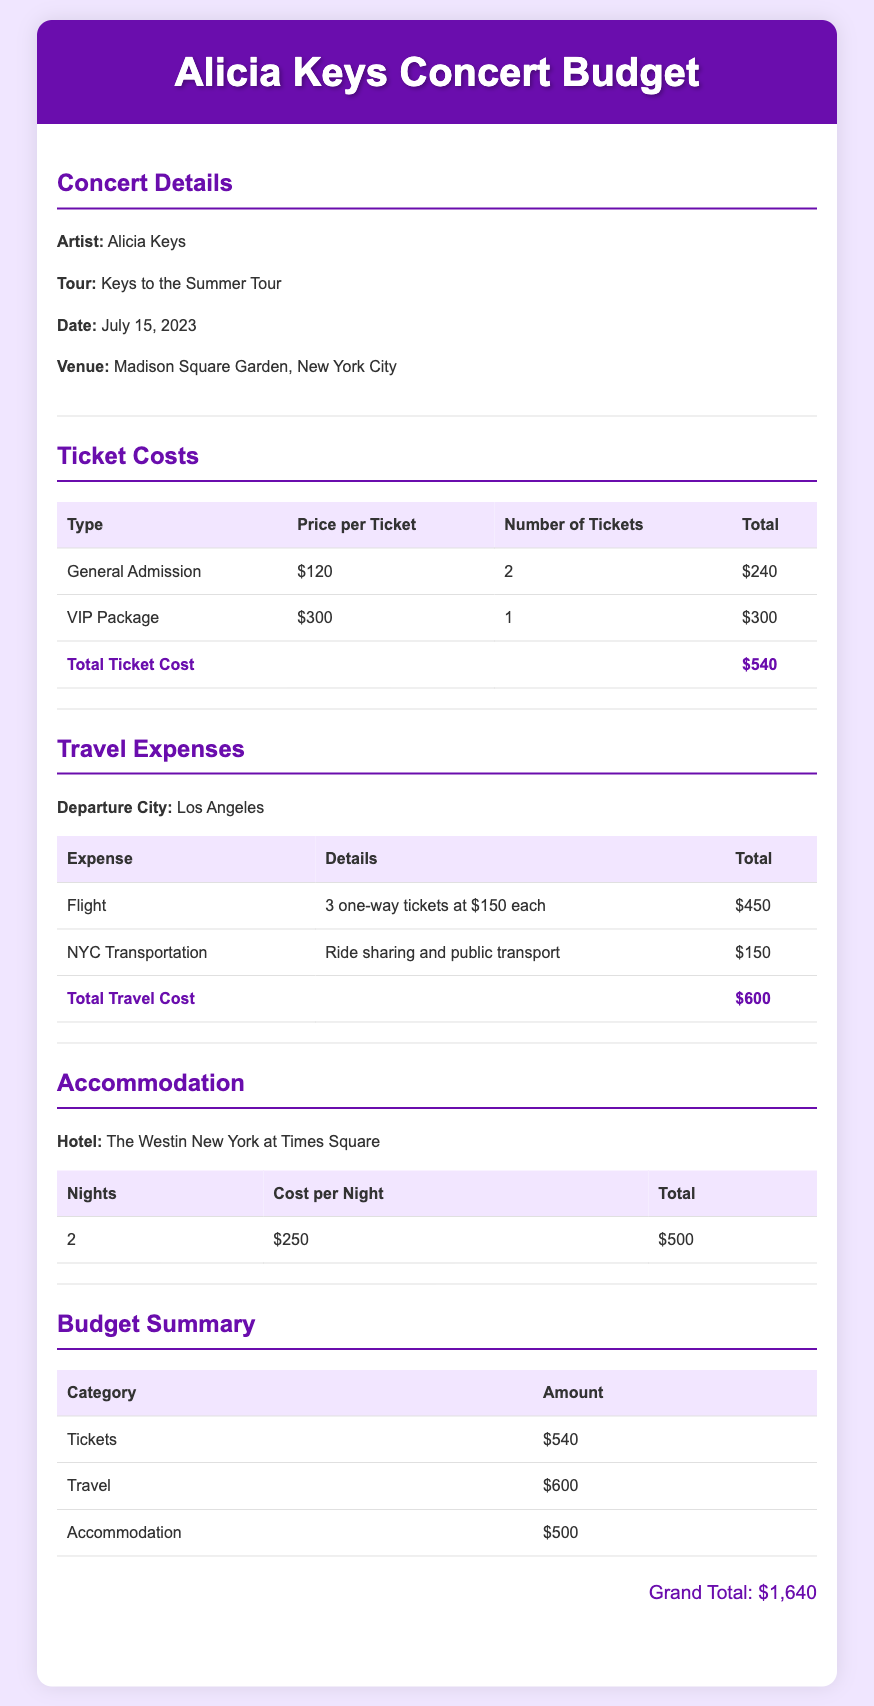What is the artist's name? The document specifies that the artist is Alicia Keys, who is the main focus of the concert.
Answer: Alicia Keys What is the venue of the concert? The venue is clearly stated in the document as Madison Square Garden, which pertains to where the concert takes place.
Answer: Madison Square Garden How many tickets were purchased? The document details the number of tickets purchased in the ticket section, which includes both general admission and VIP package tickets.
Answer: 3 What is the total ticket cost? The total ticket cost is provided in the ticket section, summing up all ticket types according to the amounts listed.
Answer: $540 What type of transportation is included in travel expenses? The document describes the means of transportation under travel expenses, specifying ride sharing and public transport.
Answer: Ride sharing and public transport What is the cost per night for accommodation? The accommodation section indicates the price per night for the hotel stay during the concert.
Answer: $250 What is the grand total of the budget? The grand total is calculated from the summation of all expense categories outlined in the budget summary, showing a comprehensive overview of the costs.
Answer: $1,640 How many nights will be spent in accommodation? The accommodation section specifies the duration of the hotel stay for the concert-related expenses.
Answer: 2 What is included in the VIP package? While the document does not detail the specifics of the VIP package, it mentions its cost and the quantity purchased, indicating it's an upgraded ticket.
Answer: Not specified 